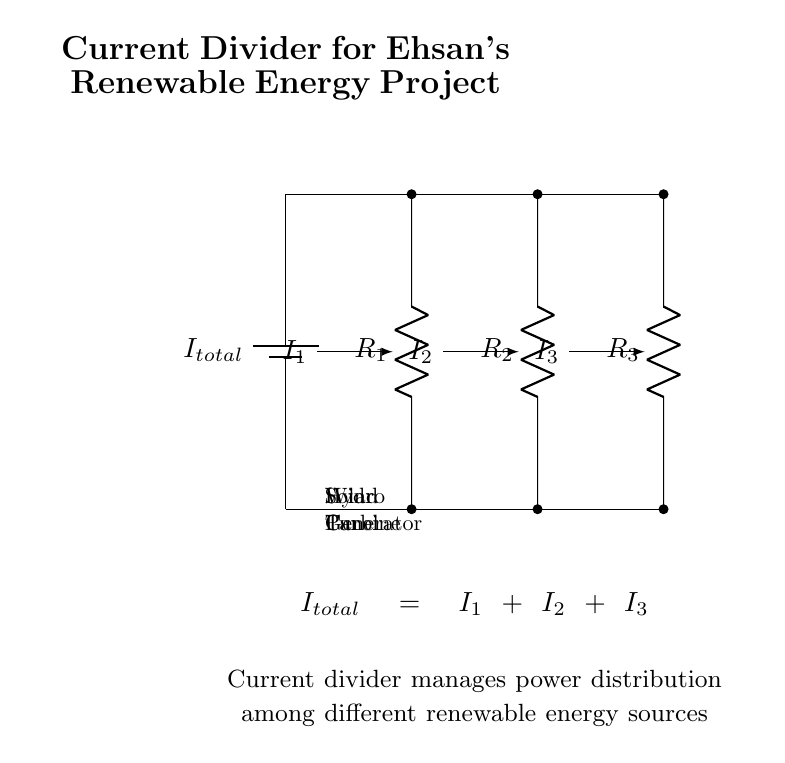What components are in the circuit? The circuit contains a total of three resistors representing the solar panel, wind turbine, and hydro generator, and one total current source.
Answer: three resistors and one current source What is the total current represented in the circuit? The total current is represented as I total, which is the sum of the currents through each branch of the circuit.
Answer: I total How many branches are there in the current divider? The circuit diagram shows three parallel branches for power distribution from different energy sources.
Answer: three Which renewable energy sources are represented in the circuit? The three renewable energy sources are the solar panel, wind turbine, and hydro generator, each associated with a resistor in the circuit.
Answer: solar panel, wind turbine, hydro generator How is the total current divided among the branches? The total current is divided among the branches based on the resistance of each branch according to Ohm's law, where lower resistance results in higher current.
Answer: based on resistance What is the equation governing current distribution in this circuit? The governing equation states that the total current is equal to the sum of the currents through the individual branches: I total = I 1 + I 2 + I 3.
Answer: I total = I 1 + I 2 + I 3 How does changing the resistance in one branch affect current distribution? Changing the resistance in one branch will inversely affect its current; increasing resistance will decrease current in that branch, resulting in more current distributed to the other branches.
Answer: inversely affects the current 